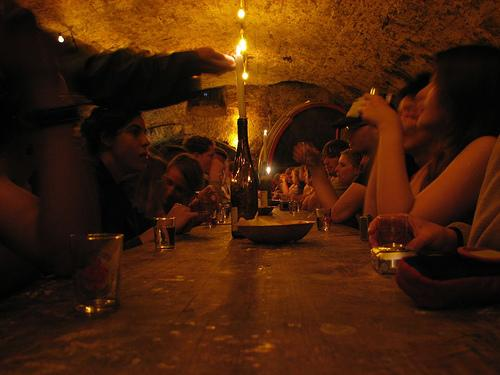What is the name for this style of table?

Choices:
A) elongated table
B) long table
C) rectangle table
D) refectory table refectory table 